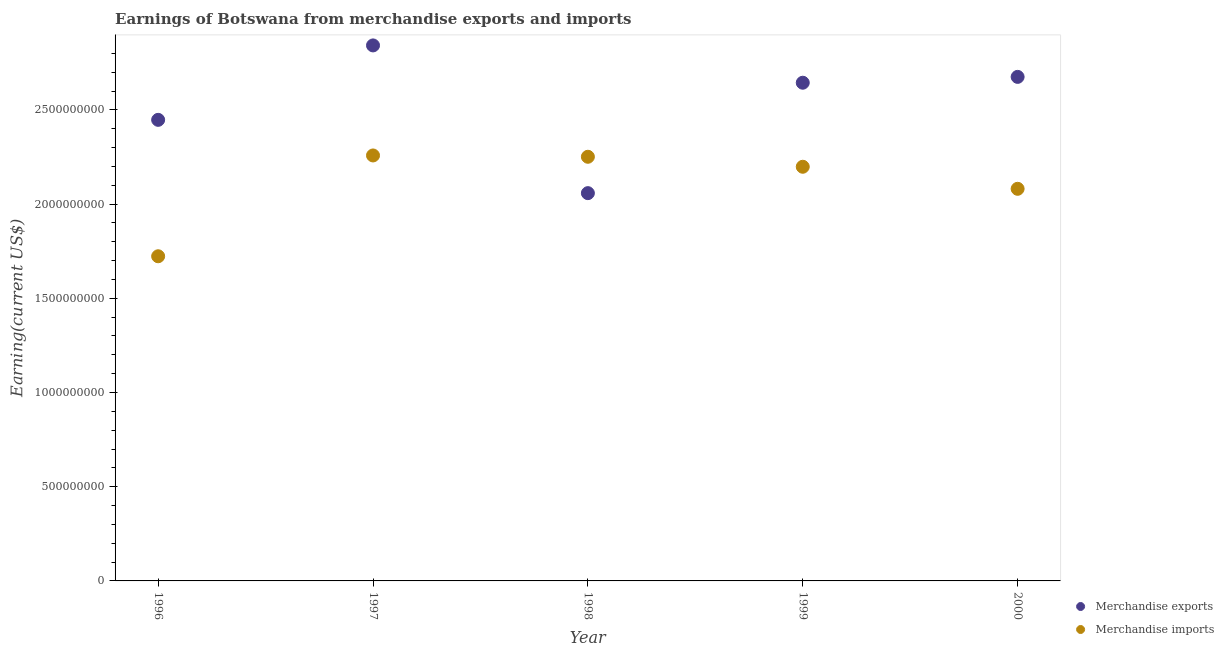What is the earnings from merchandise imports in 1998?
Provide a succinct answer. 2.25e+09. Across all years, what is the maximum earnings from merchandise exports?
Give a very brief answer. 2.84e+09. Across all years, what is the minimum earnings from merchandise imports?
Ensure brevity in your answer.  1.72e+09. What is the total earnings from merchandise imports in the graph?
Provide a short and direct response. 1.05e+1. What is the difference between the earnings from merchandise imports in 1996 and that in 1998?
Give a very brief answer. -5.28e+08. What is the difference between the earnings from merchandise imports in 1997 and the earnings from merchandise exports in 2000?
Ensure brevity in your answer.  -4.17e+08. What is the average earnings from merchandise exports per year?
Your answer should be compact. 2.53e+09. In the year 1998, what is the difference between the earnings from merchandise exports and earnings from merchandise imports?
Keep it short and to the point. -1.93e+08. What is the ratio of the earnings from merchandise imports in 1998 to that in 2000?
Offer a very short reply. 1.08. Is the earnings from merchandise imports in 1996 less than that in 1999?
Offer a very short reply. Yes. Is the difference between the earnings from merchandise imports in 1997 and 1998 greater than the difference between the earnings from merchandise exports in 1997 and 1998?
Give a very brief answer. No. What is the difference between the highest and the second highest earnings from merchandise exports?
Give a very brief answer. 1.67e+08. What is the difference between the highest and the lowest earnings from merchandise exports?
Your answer should be very brief. 7.84e+08. Is the sum of the earnings from merchandise imports in 1998 and 2000 greater than the maximum earnings from merchandise exports across all years?
Make the answer very short. Yes. Does the earnings from merchandise exports monotonically increase over the years?
Keep it short and to the point. No. Is the earnings from merchandise exports strictly greater than the earnings from merchandise imports over the years?
Make the answer very short. No. Is the earnings from merchandise imports strictly less than the earnings from merchandise exports over the years?
Offer a very short reply. No. How many dotlines are there?
Your answer should be very brief. 2. How many years are there in the graph?
Offer a very short reply. 5. What is the difference between two consecutive major ticks on the Y-axis?
Your answer should be very brief. 5.00e+08. Are the values on the major ticks of Y-axis written in scientific E-notation?
Offer a very short reply. No. Does the graph contain any zero values?
Your answer should be very brief. No. Where does the legend appear in the graph?
Make the answer very short. Bottom right. How are the legend labels stacked?
Your answer should be very brief. Vertical. What is the title of the graph?
Give a very brief answer. Earnings of Botswana from merchandise exports and imports. Does "Constant 2005 US$" appear as one of the legend labels in the graph?
Your answer should be compact. No. What is the label or title of the Y-axis?
Provide a short and direct response. Earning(current US$). What is the Earning(current US$) in Merchandise exports in 1996?
Offer a terse response. 2.45e+09. What is the Earning(current US$) of Merchandise imports in 1996?
Provide a short and direct response. 1.72e+09. What is the Earning(current US$) of Merchandise exports in 1997?
Keep it short and to the point. 2.84e+09. What is the Earning(current US$) in Merchandise imports in 1997?
Provide a short and direct response. 2.26e+09. What is the Earning(current US$) in Merchandise exports in 1998?
Provide a succinct answer. 2.06e+09. What is the Earning(current US$) of Merchandise imports in 1998?
Provide a short and direct response. 2.25e+09. What is the Earning(current US$) in Merchandise exports in 1999?
Your answer should be compact. 2.64e+09. What is the Earning(current US$) of Merchandise imports in 1999?
Ensure brevity in your answer.  2.20e+09. What is the Earning(current US$) in Merchandise exports in 2000?
Keep it short and to the point. 2.68e+09. What is the Earning(current US$) of Merchandise imports in 2000?
Your answer should be compact. 2.08e+09. Across all years, what is the maximum Earning(current US$) of Merchandise exports?
Your answer should be compact. 2.84e+09. Across all years, what is the maximum Earning(current US$) of Merchandise imports?
Ensure brevity in your answer.  2.26e+09. Across all years, what is the minimum Earning(current US$) of Merchandise exports?
Offer a terse response. 2.06e+09. Across all years, what is the minimum Earning(current US$) in Merchandise imports?
Keep it short and to the point. 1.72e+09. What is the total Earning(current US$) of Merchandise exports in the graph?
Your answer should be very brief. 1.27e+1. What is the total Earning(current US$) in Merchandise imports in the graph?
Offer a very short reply. 1.05e+1. What is the difference between the Earning(current US$) of Merchandise exports in 1996 and that in 1997?
Provide a short and direct response. -3.95e+08. What is the difference between the Earning(current US$) of Merchandise imports in 1996 and that in 1997?
Make the answer very short. -5.35e+08. What is the difference between the Earning(current US$) in Merchandise exports in 1996 and that in 1998?
Offer a terse response. 3.89e+08. What is the difference between the Earning(current US$) in Merchandise imports in 1996 and that in 1998?
Keep it short and to the point. -5.28e+08. What is the difference between the Earning(current US$) in Merchandise exports in 1996 and that in 1999?
Give a very brief answer. -1.97e+08. What is the difference between the Earning(current US$) in Merchandise imports in 1996 and that in 1999?
Provide a succinct answer. -4.75e+08. What is the difference between the Earning(current US$) in Merchandise exports in 1996 and that in 2000?
Make the answer very short. -2.28e+08. What is the difference between the Earning(current US$) of Merchandise imports in 1996 and that in 2000?
Your answer should be very brief. -3.58e+08. What is the difference between the Earning(current US$) in Merchandise exports in 1997 and that in 1998?
Offer a very short reply. 7.84e+08. What is the difference between the Earning(current US$) in Merchandise exports in 1997 and that in 1999?
Make the answer very short. 1.98e+08. What is the difference between the Earning(current US$) in Merchandise imports in 1997 and that in 1999?
Offer a terse response. 6.00e+07. What is the difference between the Earning(current US$) of Merchandise exports in 1997 and that in 2000?
Provide a succinct answer. 1.67e+08. What is the difference between the Earning(current US$) of Merchandise imports in 1997 and that in 2000?
Make the answer very short. 1.77e+08. What is the difference between the Earning(current US$) in Merchandise exports in 1998 and that in 1999?
Your answer should be compact. -5.86e+08. What is the difference between the Earning(current US$) in Merchandise imports in 1998 and that in 1999?
Offer a very short reply. 5.30e+07. What is the difference between the Earning(current US$) in Merchandise exports in 1998 and that in 2000?
Your answer should be very brief. -6.17e+08. What is the difference between the Earning(current US$) in Merchandise imports in 1998 and that in 2000?
Your answer should be very brief. 1.70e+08. What is the difference between the Earning(current US$) in Merchandise exports in 1999 and that in 2000?
Your answer should be very brief. -3.10e+07. What is the difference between the Earning(current US$) in Merchandise imports in 1999 and that in 2000?
Keep it short and to the point. 1.17e+08. What is the difference between the Earning(current US$) of Merchandise exports in 1996 and the Earning(current US$) of Merchandise imports in 1997?
Your response must be concise. 1.89e+08. What is the difference between the Earning(current US$) of Merchandise exports in 1996 and the Earning(current US$) of Merchandise imports in 1998?
Provide a succinct answer. 1.96e+08. What is the difference between the Earning(current US$) of Merchandise exports in 1996 and the Earning(current US$) of Merchandise imports in 1999?
Your answer should be very brief. 2.49e+08. What is the difference between the Earning(current US$) in Merchandise exports in 1996 and the Earning(current US$) in Merchandise imports in 2000?
Provide a succinct answer. 3.66e+08. What is the difference between the Earning(current US$) of Merchandise exports in 1997 and the Earning(current US$) of Merchandise imports in 1998?
Provide a short and direct response. 5.91e+08. What is the difference between the Earning(current US$) in Merchandise exports in 1997 and the Earning(current US$) in Merchandise imports in 1999?
Provide a short and direct response. 6.44e+08. What is the difference between the Earning(current US$) in Merchandise exports in 1997 and the Earning(current US$) in Merchandise imports in 2000?
Provide a short and direct response. 7.61e+08. What is the difference between the Earning(current US$) in Merchandise exports in 1998 and the Earning(current US$) in Merchandise imports in 1999?
Provide a succinct answer. -1.40e+08. What is the difference between the Earning(current US$) in Merchandise exports in 1998 and the Earning(current US$) in Merchandise imports in 2000?
Offer a terse response. -2.30e+07. What is the difference between the Earning(current US$) of Merchandise exports in 1999 and the Earning(current US$) of Merchandise imports in 2000?
Keep it short and to the point. 5.63e+08. What is the average Earning(current US$) in Merchandise exports per year?
Your response must be concise. 2.53e+09. What is the average Earning(current US$) in Merchandise imports per year?
Keep it short and to the point. 2.10e+09. In the year 1996, what is the difference between the Earning(current US$) in Merchandise exports and Earning(current US$) in Merchandise imports?
Make the answer very short. 7.24e+08. In the year 1997, what is the difference between the Earning(current US$) of Merchandise exports and Earning(current US$) of Merchandise imports?
Keep it short and to the point. 5.84e+08. In the year 1998, what is the difference between the Earning(current US$) in Merchandise exports and Earning(current US$) in Merchandise imports?
Make the answer very short. -1.93e+08. In the year 1999, what is the difference between the Earning(current US$) of Merchandise exports and Earning(current US$) of Merchandise imports?
Ensure brevity in your answer.  4.46e+08. In the year 2000, what is the difference between the Earning(current US$) in Merchandise exports and Earning(current US$) in Merchandise imports?
Keep it short and to the point. 5.94e+08. What is the ratio of the Earning(current US$) in Merchandise exports in 1996 to that in 1997?
Provide a succinct answer. 0.86. What is the ratio of the Earning(current US$) in Merchandise imports in 1996 to that in 1997?
Your response must be concise. 0.76. What is the ratio of the Earning(current US$) in Merchandise exports in 1996 to that in 1998?
Make the answer very short. 1.19. What is the ratio of the Earning(current US$) in Merchandise imports in 1996 to that in 1998?
Keep it short and to the point. 0.77. What is the ratio of the Earning(current US$) of Merchandise exports in 1996 to that in 1999?
Your answer should be very brief. 0.93. What is the ratio of the Earning(current US$) of Merchandise imports in 1996 to that in 1999?
Your answer should be compact. 0.78. What is the ratio of the Earning(current US$) of Merchandise exports in 1996 to that in 2000?
Offer a very short reply. 0.91. What is the ratio of the Earning(current US$) of Merchandise imports in 1996 to that in 2000?
Your answer should be compact. 0.83. What is the ratio of the Earning(current US$) of Merchandise exports in 1997 to that in 1998?
Provide a short and direct response. 1.38. What is the ratio of the Earning(current US$) in Merchandise imports in 1997 to that in 1998?
Offer a terse response. 1. What is the ratio of the Earning(current US$) in Merchandise exports in 1997 to that in 1999?
Provide a succinct answer. 1.07. What is the ratio of the Earning(current US$) in Merchandise imports in 1997 to that in 1999?
Ensure brevity in your answer.  1.03. What is the ratio of the Earning(current US$) of Merchandise exports in 1997 to that in 2000?
Keep it short and to the point. 1.06. What is the ratio of the Earning(current US$) in Merchandise imports in 1997 to that in 2000?
Your answer should be compact. 1.09. What is the ratio of the Earning(current US$) of Merchandise exports in 1998 to that in 1999?
Your response must be concise. 0.78. What is the ratio of the Earning(current US$) of Merchandise imports in 1998 to that in 1999?
Keep it short and to the point. 1.02. What is the ratio of the Earning(current US$) in Merchandise exports in 1998 to that in 2000?
Make the answer very short. 0.77. What is the ratio of the Earning(current US$) in Merchandise imports in 1998 to that in 2000?
Keep it short and to the point. 1.08. What is the ratio of the Earning(current US$) in Merchandise exports in 1999 to that in 2000?
Provide a succinct answer. 0.99. What is the ratio of the Earning(current US$) in Merchandise imports in 1999 to that in 2000?
Ensure brevity in your answer.  1.06. What is the difference between the highest and the second highest Earning(current US$) in Merchandise exports?
Your answer should be compact. 1.67e+08. What is the difference between the highest and the lowest Earning(current US$) in Merchandise exports?
Ensure brevity in your answer.  7.84e+08. What is the difference between the highest and the lowest Earning(current US$) in Merchandise imports?
Offer a terse response. 5.35e+08. 